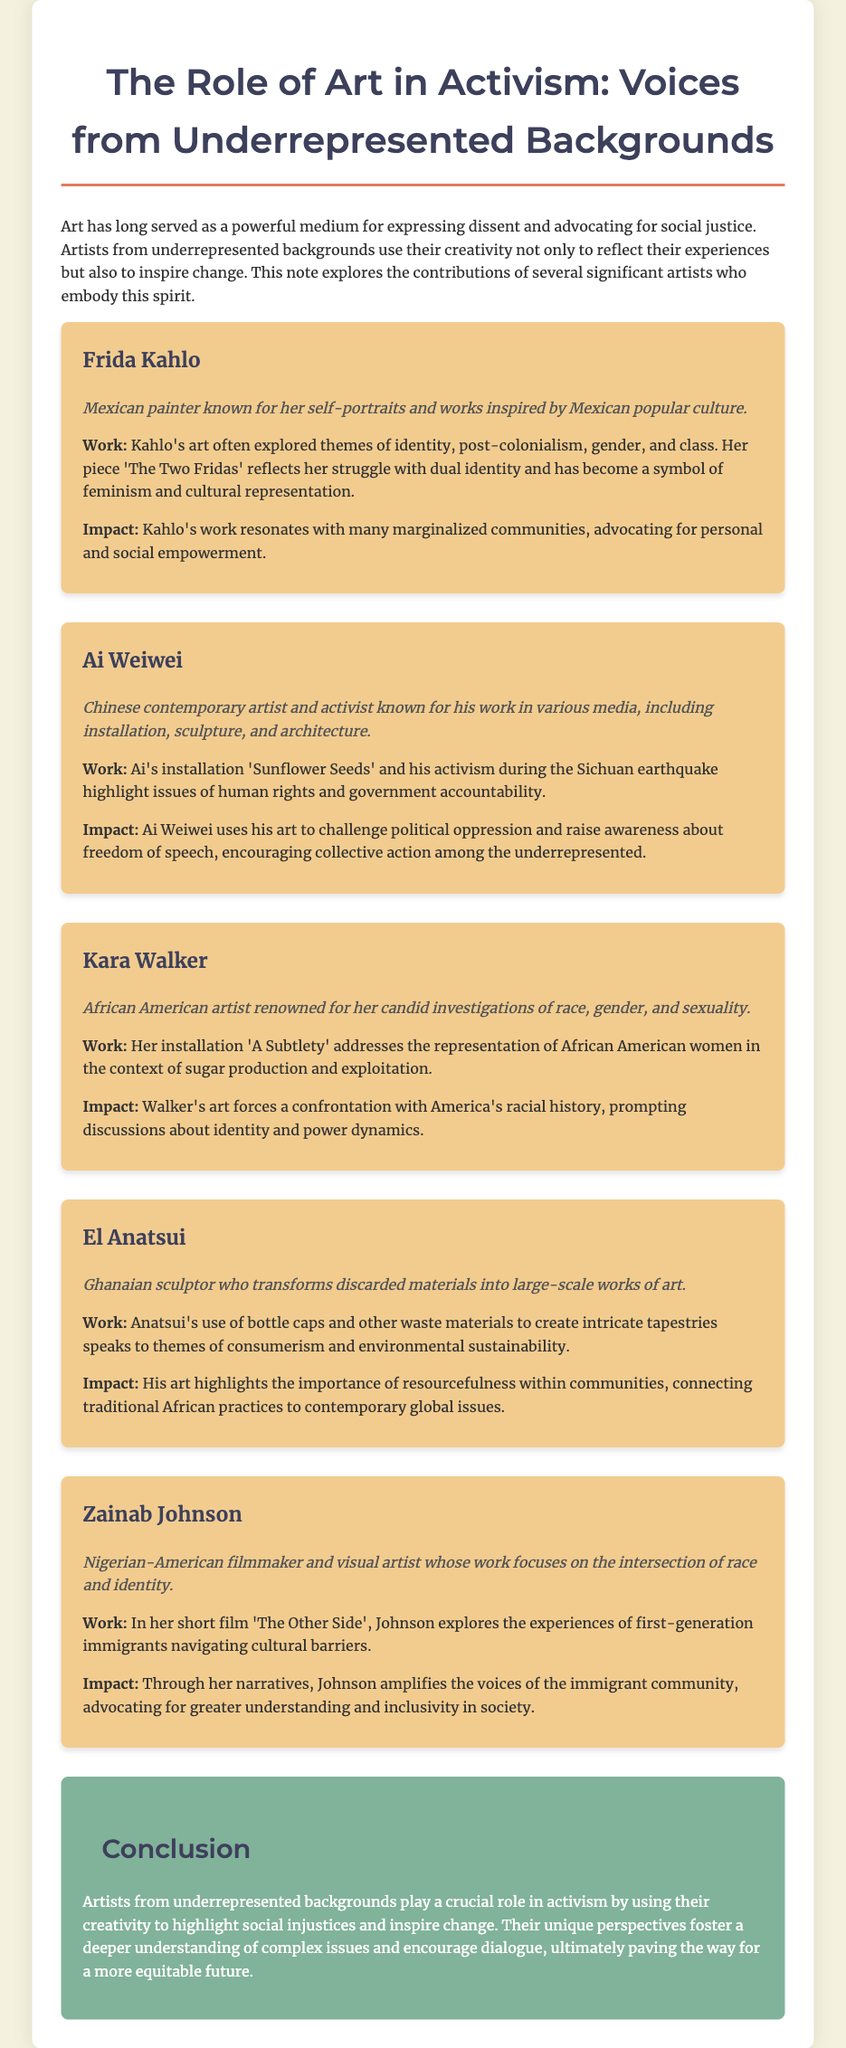What is the title of the document? The title is prominently displayed at the top of the document.
Answer: The Role of Art in Activism: Voices from Underrepresented Backgrounds Who is the artist known for 'The Two Fridas'? This information can be found in the section dedicated to Frida Kahlo.
Answer: Frida Kahlo What medium does Ai Weiwei primarily work in? The document describes Ai Weiwei as known for his work in various media, including installation, sculpture, and architecture.
Answer: Various media What themes does Kara Walker's art investigate? The document mentions that Walker's art focuses on race, gender, and sexuality.
Answer: Race, gender, and sexuality What material does El Anatsui use to create his artworks? The document states that Anatsui transforms discarded materials, specifically mentioning bottle caps and waste materials.
Answer: Bottle caps How many artists are mentioned in the document? By counting the individual artist sections within the document, we can determine the total.
Answer: Five What does Zainab Johnson's film 'The Other Side' explore? The document explains that Johnson's film explores the experiences of first-generation immigrants.
Answer: Experiences of first-generation immigrants What is the overall purpose of the artists described in the document? The conclusion outlines that the artists use their creativity to highlight social injustices and inspire change.
Answer: Highlight social injustices and inspire change 